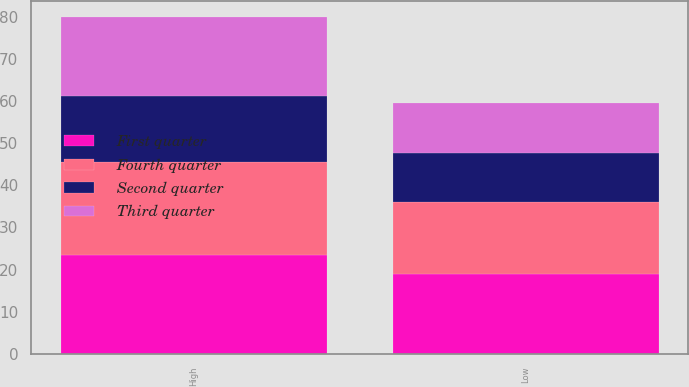Convert chart to OTSL. <chart><loc_0><loc_0><loc_500><loc_500><stacked_bar_chart><ecel><fcel>High<fcel>Low<nl><fcel>First quarter<fcel>23.43<fcel>18.93<nl><fcel>Fourth quarter<fcel>22.05<fcel>17.2<nl><fcel>Third quarter<fcel>18.72<fcel>11.9<nl><fcel>Second quarter<fcel>15.75<fcel>11.51<nl></chart> 